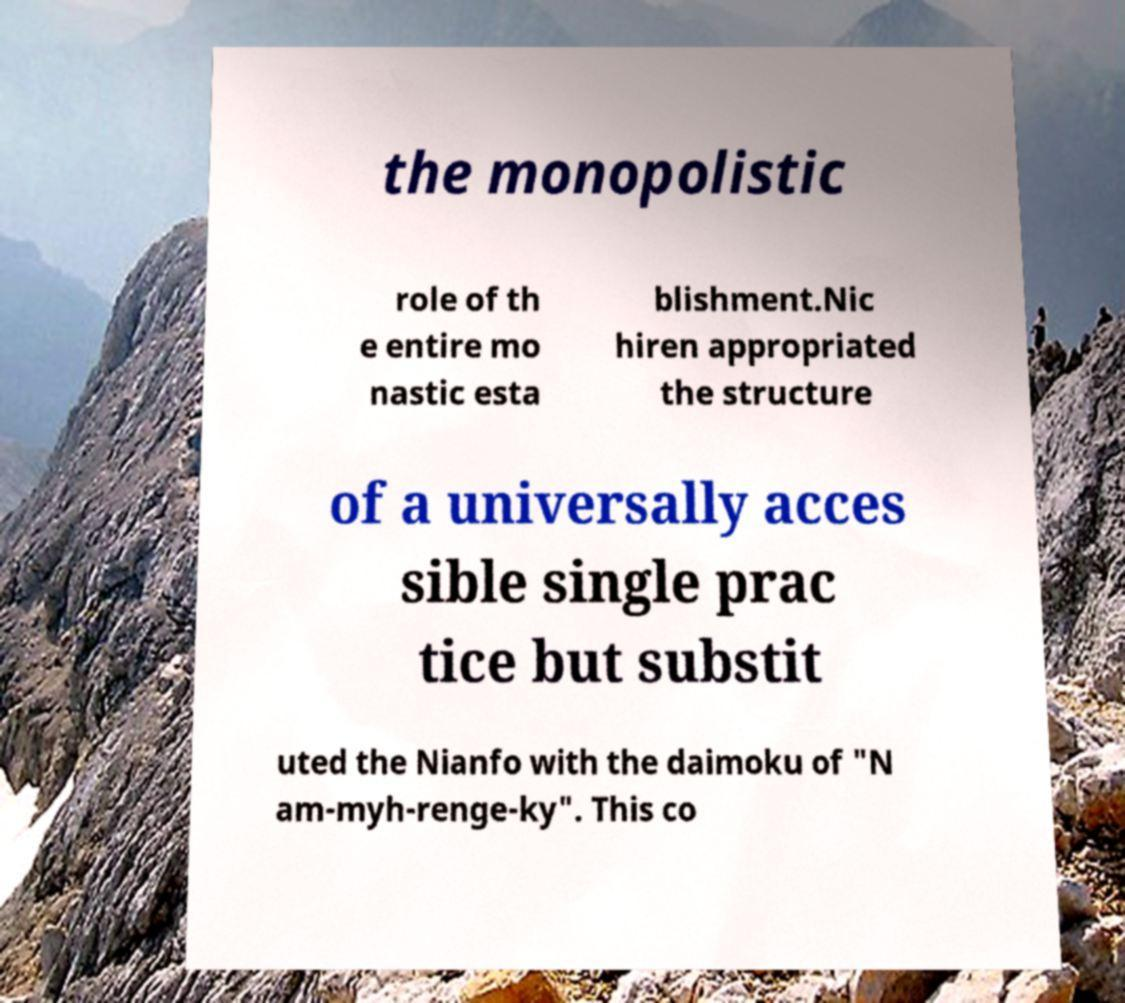Can you accurately transcribe the text from the provided image for me? the monopolistic role of th e entire mo nastic esta blishment.Nic hiren appropriated the structure of a universally acces sible single prac tice but substit uted the Nianfo with the daimoku of "N am-myh-renge-ky". This co 